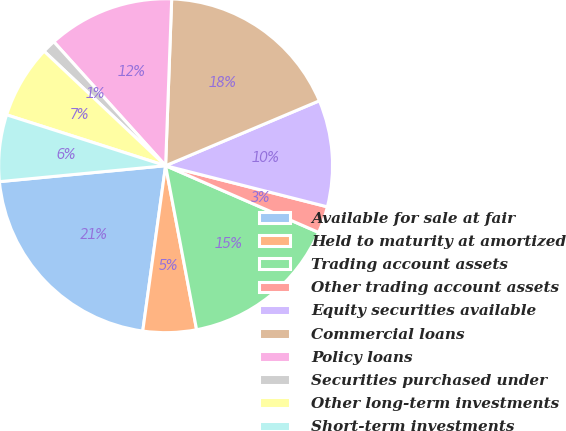Convert chart to OTSL. <chart><loc_0><loc_0><loc_500><loc_500><pie_chart><fcel>Available for sale at fair<fcel>Held to maturity at amortized<fcel>Trading account assets<fcel>Other trading account assets<fcel>Equity securities available<fcel>Commercial loans<fcel>Policy loans<fcel>Securities purchased under<fcel>Other long-term investments<fcel>Short-term investments<nl><fcel>21.29%<fcel>5.16%<fcel>15.48%<fcel>2.58%<fcel>10.32%<fcel>18.06%<fcel>12.26%<fcel>1.29%<fcel>7.1%<fcel>6.45%<nl></chart> 